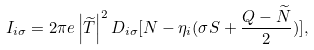Convert formula to latex. <formula><loc_0><loc_0><loc_500><loc_500>I _ { i \sigma } = 2 \pi e \left | \widetilde { T } \right | ^ { 2 } D _ { i \sigma } [ N - \eta _ { i } ( \sigma S + \frac { Q - \widetilde { N } } { 2 } ) ] ,</formula> 